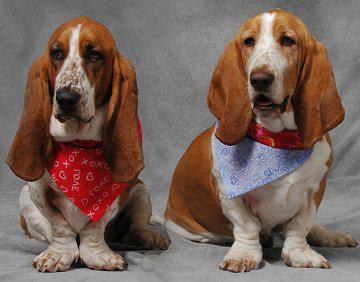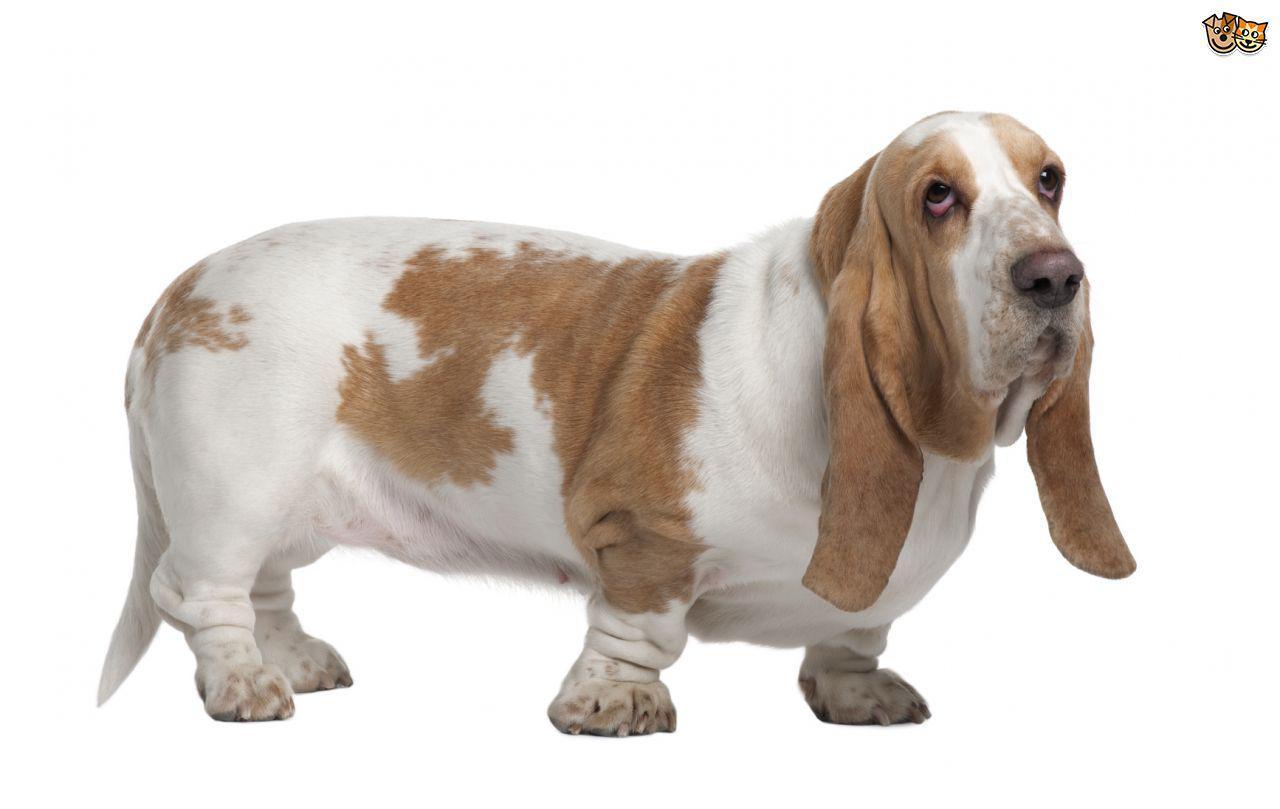The first image is the image on the left, the second image is the image on the right. Evaluate the accuracy of this statement regarding the images: "One image shows a basset in profile on a white background.". Is it true? Answer yes or no. Yes. The first image is the image on the left, the second image is the image on the right. Given the left and right images, does the statement "An image shows a brown and white basset on grass in profile facing left." hold true? Answer yes or no. No. 